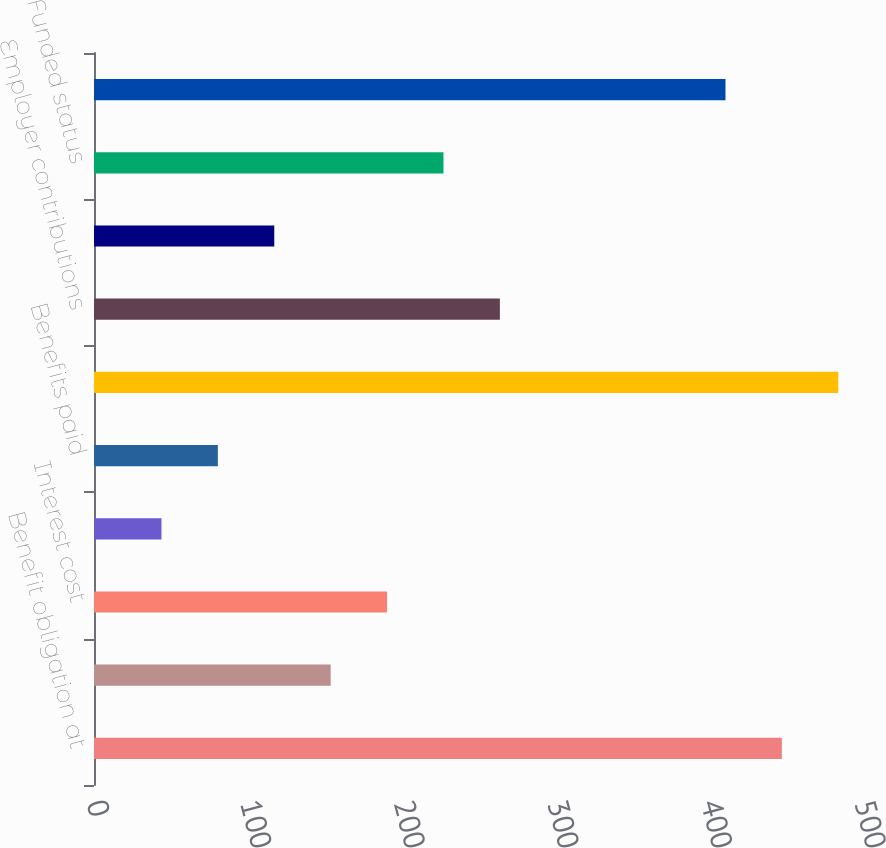<chart> <loc_0><loc_0><loc_500><loc_500><bar_chart><fcel>Benefit obligation at<fcel>Service cost<fcel>Interest cost<fcel>Actuarial loss (gain)<fcel>Benefits paid<fcel>Benefit obligation at end of<fcel>Employer contributions<fcel>Benefits paid from plan assets<fcel>Funded status<fcel>Unrecognized net actuarial<nl><fcel>447.84<fcel>154.08<fcel>190.8<fcel>43.92<fcel>80.64<fcel>484.56<fcel>264.24<fcel>117.36<fcel>227.52<fcel>411.12<nl></chart> 